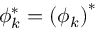<formula> <loc_0><loc_0><loc_500><loc_500>\phi _ { k } ^ { * } = \left ( \phi _ { k } \right ) ^ { * }</formula> 